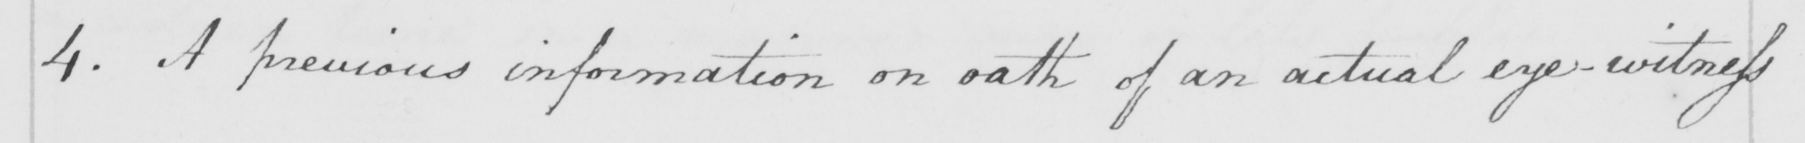Please provide the text content of this handwritten line. 4 . A previous information on oath of an actual eye-witness 